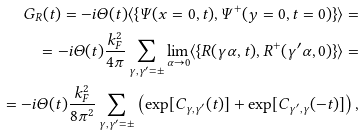Convert formula to latex. <formula><loc_0><loc_0><loc_500><loc_500>G _ { R } ( t ) = - i \Theta ( t ) \langle \{ \Psi ( x = 0 , t ) , \Psi ^ { + } ( y = 0 , t = 0 ) \} \rangle = \\ = - i \Theta ( t ) \frac { k _ { F } ^ { 2 } } { 4 \pi } \sum _ { \gamma , \gamma ^ { \prime } = \pm } \lim _ { \alpha \rightarrow 0 } \langle \{ R ( \gamma \alpha , t ) , R ^ { + } ( \gamma ^ { \prime } \alpha , 0 ) \} \rangle = \\ = - i \Theta ( t ) \frac { k _ { F } ^ { 2 } } { 8 \pi ^ { 2 } } \sum _ { \gamma , \gamma ^ { \prime } = \pm } \left ( \exp [ C _ { \gamma , \gamma ^ { \prime } } ( t ) ] + \exp [ C _ { \gamma ^ { \prime } , \gamma } ( - t ) ] \right ) ,</formula> 